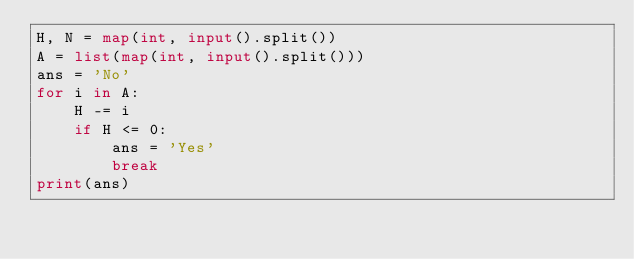Convert code to text. <code><loc_0><loc_0><loc_500><loc_500><_Python_>H, N = map(int, input().split())
A = list(map(int, input().split()))
ans = 'No'
for i in A:
    H -= i
    if H <= 0:
        ans = 'Yes'
        break
print(ans)</code> 